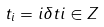Convert formula to latex. <formula><loc_0><loc_0><loc_500><loc_500>t _ { i } = i \delta t i \in Z</formula> 